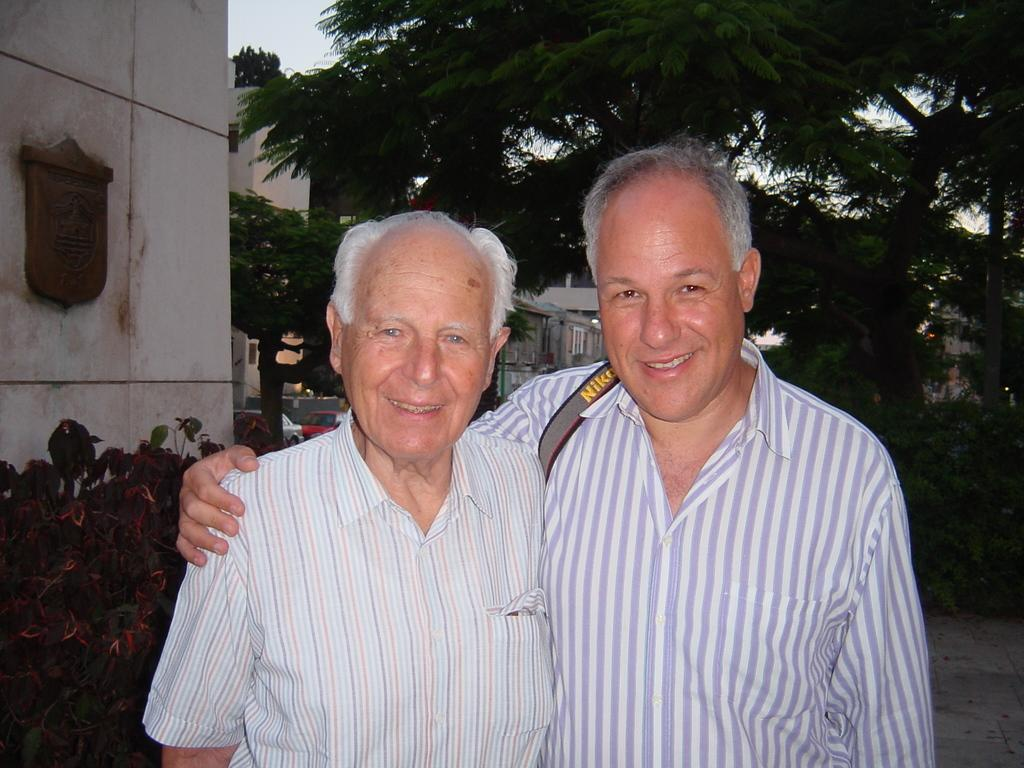<image>
Describe the image concisely. A man with a striped shirt on and a Nikon strap over his shoulder poses for a photo with another man also wearing a striped shirt. 